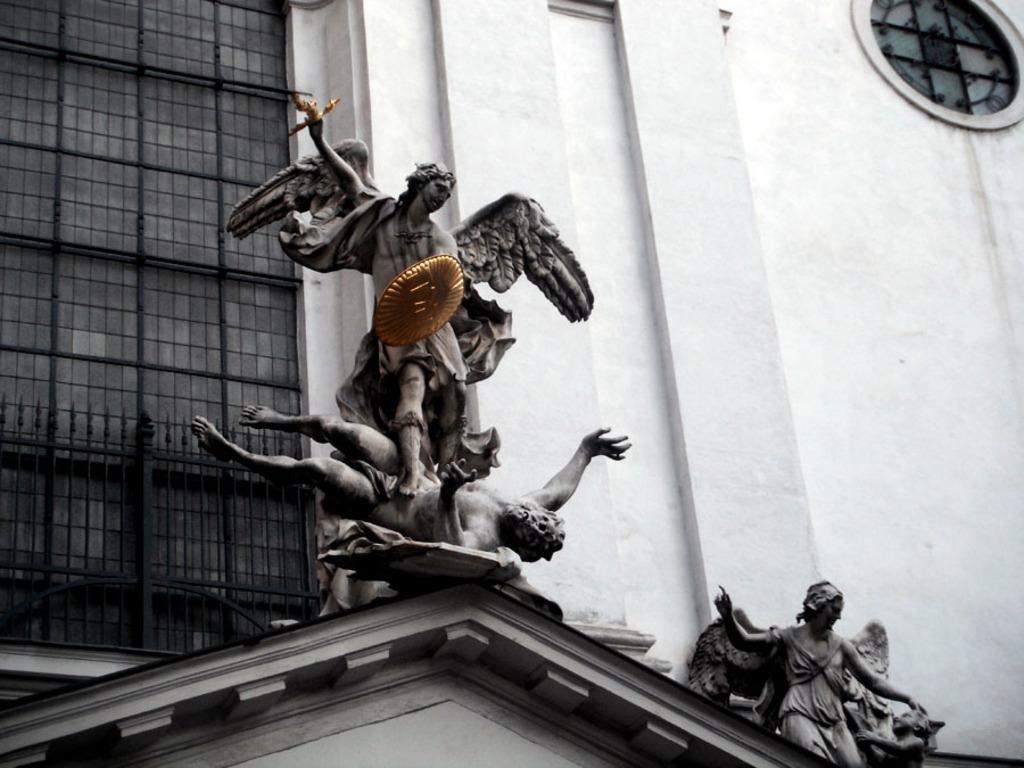Please provide a concise description of this image. In the middle these are the statues of humans behind them it's a building. 